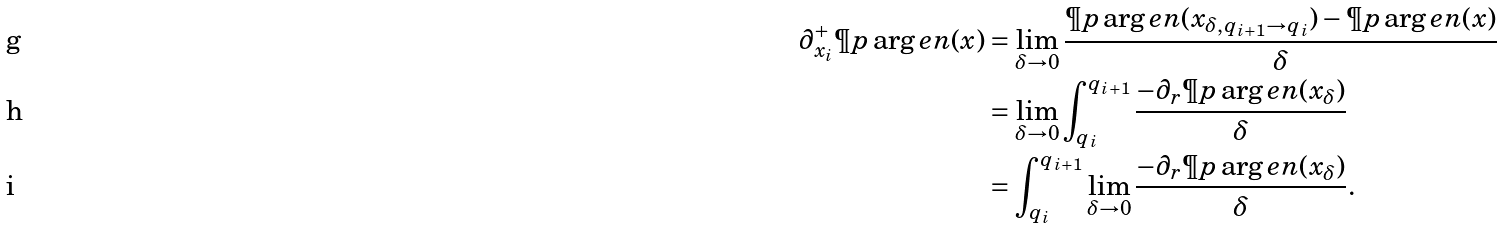<formula> <loc_0><loc_0><loc_500><loc_500>\partial ^ { + } _ { x _ { i } } \P p \arg e n ( x ) & = \lim _ { \delta \to 0 } \frac { \P p \arg e n ( x _ { \delta , q _ { i + 1 } \to q _ { i } } ) - \P p \arg e n ( x ) } { \delta } \\ & = \lim _ { \delta \to 0 } \int _ { q _ { i } } ^ { q _ { i + 1 } } \frac { - \partial _ { r } \P p \arg e n ( x _ { \delta } ) } { \delta } \\ & = \int _ { q _ { i } } ^ { q _ { i + 1 } } \lim _ { \delta \to 0 } \frac { - \partial _ { r } \P p \arg e n ( x _ { \delta } ) } { \delta } .</formula> 